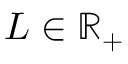Convert formula to latex. <formula><loc_0><loc_0><loc_500><loc_500>L \in \mathbb { R } _ { + }</formula> 